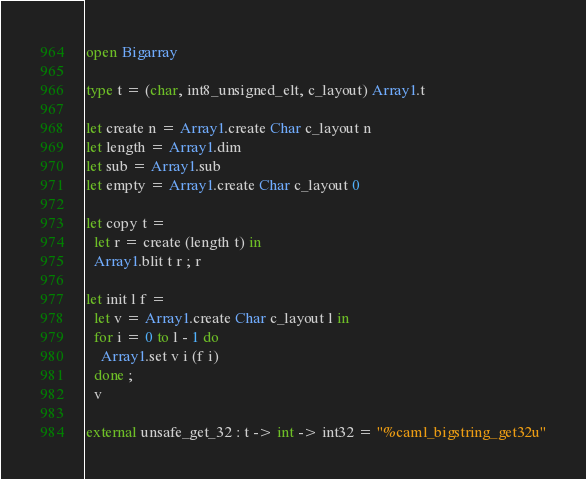<code> <loc_0><loc_0><loc_500><loc_500><_OCaml_>open Bigarray

type t = (char, int8_unsigned_elt, c_layout) Array1.t

let create n = Array1.create Char c_layout n
let length = Array1.dim
let sub = Array1.sub
let empty = Array1.create Char c_layout 0

let copy t =
  let r = create (length t) in
  Array1.blit t r ; r

let init l f =
  let v = Array1.create Char c_layout l in
  for i = 0 to l - 1 do
    Array1.set v i (f i)
  done ;
  v

external unsafe_get_32 : t -> int -> int32 = "%caml_bigstring_get32u"</code> 